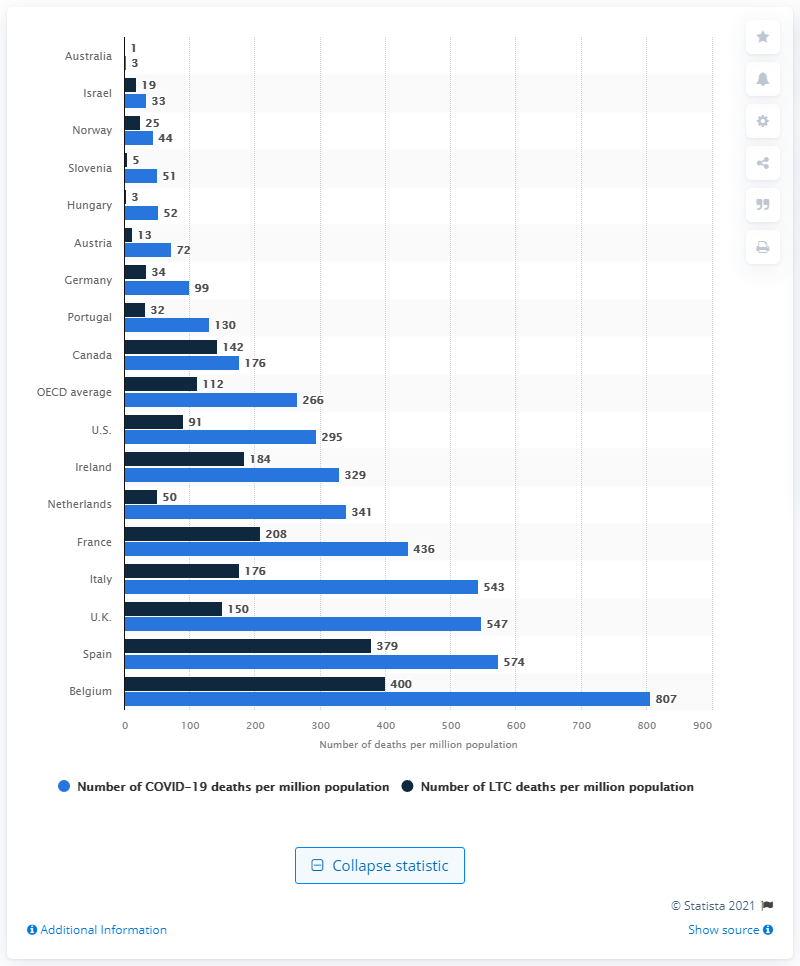Highlight a few significant elements in this photo. As of May 25, 2020, the United States had recorded 295 deaths per million population due to COVID-19. As of May 25, 2020, a total of 91 long-term care residents in the United States had died from COVID-19. 